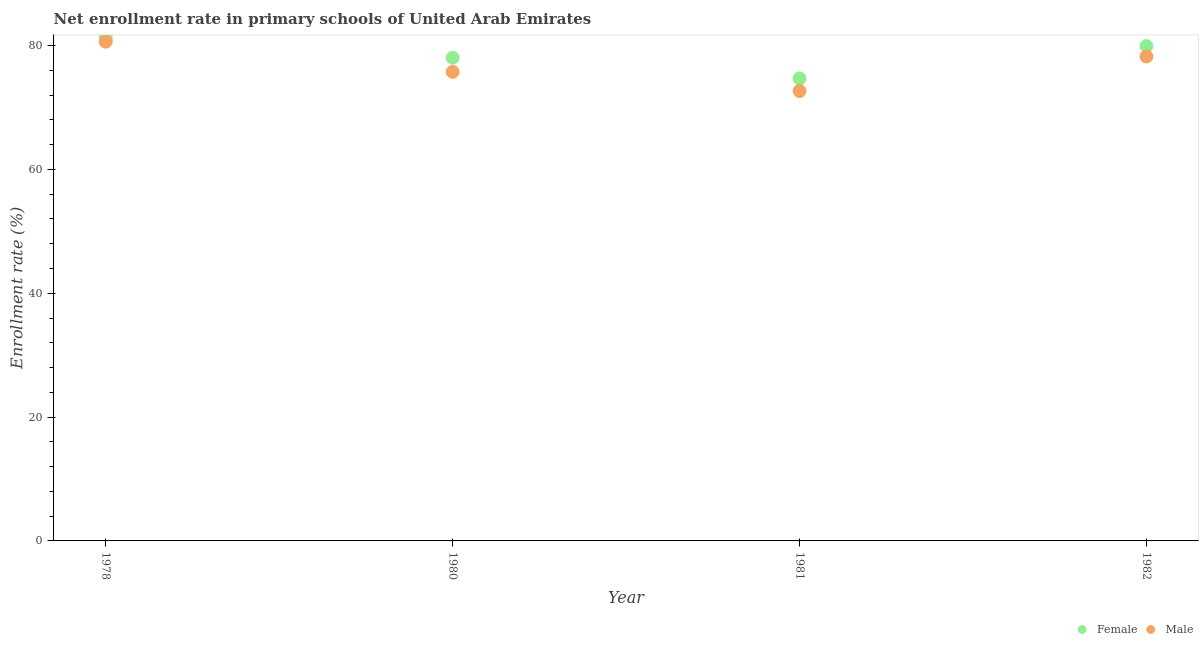How many different coloured dotlines are there?
Provide a short and direct response. 2. What is the enrollment rate of female students in 1982?
Your response must be concise. 79.92. Across all years, what is the maximum enrollment rate of female students?
Make the answer very short. 81.29. Across all years, what is the minimum enrollment rate of male students?
Provide a succinct answer. 72.66. In which year was the enrollment rate of male students maximum?
Provide a succinct answer. 1978. What is the total enrollment rate of female students in the graph?
Make the answer very short. 313.94. What is the difference between the enrollment rate of male students in 1978 and that in 1980?
Ensure brevity in your answer.  4.88. What is the difference between the enrollment rate of female students in 1982 and the enrollment rate of male students in 1980?
Your answer should be compact. 4.16. What is the average enrollment rate of male students per year?
Your answer should be very brief. 76.82. In the year 1980, what is the difference between the enrollment rate of male students and enrollment rate of female students?
Your answer should be very brief. -2.28. In how many years, is the enrollment rate of male students greater than 68 %?
Make the answer very short. 4. What is the ratio of the enrollment rate of male students in 1978 to that in 1982?
Offer a very short reply. 1.03. What is the difference between the highest and the second highest enrollment rate of female students?
Your response must be concise. 1.38. What is the difference between the highest and the lowest enrollment rate of male students?
Provide a short and direct response. 7.97. Is the sum of the enrollment rate of male students in 1978 and 1982 greater than the maximum enrollment rate of female students across all years?
Provide a short and direct response. Yes. Is the enrollment rate of female students strictly less than the enrollment rate of male students over the years?
Provide a short and direct response. No. How many years are there in the graph?
Your response must be concise. 4. Does the graph contain any zero values?
Ensure brevity in your answer.  No. Does the graph contain grids?
Keep it short and to the point. No. Where does the legend appear in the graph?
Make the answer very short. Bottom right. How many legend labels are there?
Keep it short and to the point. 2. How are the legend labels stacked?
Your answer should be very brief. Horizontal. What is the title of the graph?
Your answer should be compact. Net enrollment rate in primary schools of United Arab Emirates. Does "Drinking water services" appear as one of the legend labels in the graph?
Offer a very short reply. No. What is the label or title of the Y-axis?
Your answer should be very brief. Enrollment rate (%). What is the Enrollment rate (%) of Female in 1978?
Keep it short and to the point. 81.29. What is the Enrollment rate (%) of Male in 1978?
Ensure brevity in your answer.  80.63. What is the Enrollment rate (%) of Female in 1980?
Provide a succinct answer. 78.03. What is the Enrollment rate (%) in Male in 1980?
Offer a terse response. 75.75. What is the Enrollment rate (%) of Female in 1981?
Provide a succinct answer. 74.7. What is the Enrollment rate (%) in Male in 1981?
Make the answer very short. 72.66. What is the Enrollment rate (%) of Female in 1982?
Keep it short and to the point. 79.92. What is the Enrollment rate (%) of Male in 1982?
Your answer should be compact. 78.23. Across all years, what is the maximum Enrollment rate (%) of Female?
Your answer should be compact. 81.29. Across all years, what is the maximum Enrollment rate (%) of Male?
Offer a terse response. 80.63. Across all years, what is the minimum Enrollment rate (%) of Female?
Offer a very short reply. 74.7. Across all years, what is the minimum Enrollment rate (%) in Male?
Make the answer very short. 72.66. What is the total Enrollment rate (%) in Female in the graph?
Offer a very short reply. 313.94. What is the total Enrollment rate (%) of Male in the graph?
Keep it short and to the point. 307.27. What is the difference between the Enrollment rate (%) of Female in 1978 and that in 1980?
Your answer should be compact. 3.26. What is the difference between the Enrollment rate (%) of Male in 1978 and that in 1980?
Provide a short and direct response. 4.88. What is the difference between the Enrollment rate (%) of Female in 1978 and that in 1981?
Keep it short and to the point. 6.6. What is the difference between the Enrollment rate (%) in Male in 1978 and that in 1981?
Make the answer very short. 7.97. What is the difference between the Enrollment rate (%) of Female in 1978 and that in 1982?
Provide a succinct answer. 1.38. What is the difference between the Enrollment rate (%) in Male in 1978 and that in 1982?
Your answer should be compact. 2.4. What is the difference between the Enrollment rate (%) in Female in 1980 and that in 1981?
Make the answer very short. 3.34. What is the difference between the Enrollment rate (%) in Male in 1980 and that in 1981?
Your answer should be compact. 3.09. What is the difference between the Enrollment rate (%) of Female in 1980 and that in 1982?
Provide a succinct answer. -1.88. What is the difference between the Enrollment rate (%) of Male in 1980 and that in 1982?
Your answer should be compact. -2.48. What is the difference between the Enrollment rate (%) of Female in 1981 and that in 1982?
Make the answer very short. -5.22. What is the difference between the Enrollment rate (%) of Male in 1981 and that in 1982?
Ensure brevity in your answer.  -5.57. What is the difference between the Enrollment rate (%) of Female in 1978 and the Enrollment rate (%) of Male in 1980?
Make the answer very short. 5.54. What is the difference between the Enrollment rate (%) in Female in 1978 and the Enrollment rate (%) in Male in 1981?
Ensure brevity in your answer.  8.63. What is the difference between the Enrollment rate (%) in Female in 1978 and the Enrollment rate (%) in Male in 1982?
Your answer should be very brief. 3.06. What is the difference between the Enrollment rate (%) of Female in 1980 and the Enrollment rate (%) of Male in 1981?
Your answer should be very brief. 5.37. What is the difference between the Enrollment rate (%) in Female in 1980 and the Enrollment rate (%) in Male in 1982?
Keep it short and to the point. -0.2. What is the difference between the Enrollment rate (%) of Female in 1981 and the Enrollment rate (%) of Male in 1982?
Make the answer very short. -3.54. What is the average Enrollment rate (%) of Female per year?
Offer a very short reply. 78.48. What is the average Enrollment rate (%) of Male per year?
Your answer should be very brief. 76.82. In the year 1978, what is the difference between the Enrollment rate (%) in Female and Enrollment rate (%) in Male?
Keep it short and to the point. 0.66. In the year 1980, what is the difference between the Enrollment rate (%) in Female and Enrollment rate (%) in Male?
Your response must be concise. 2.28. In the year 1981, what is the difference between the Enrollment rate (%) in Female and Enrollment rate (%) in Male?
Keep it short and to the point. 2.03. In the year 1982, what is the difference between the Enrollment rate (%) in Female and Enrollment rate (%) in Male?
Ensure brevity in your answer.  1.68. What is the ratio of the Enrollment rate (%) of Female in 1978 to that in 1980?
Provide a short and direct response. 1.04. What is the ratio of the Enrollment rate (%) in Male in 1978 to that in 1980?
Provide a succinct answer. 1.06. What is the ratio of the Enrollment rate (%) of Female in 1978 to that in 1981?
Your answer should be compact. 1.09. What is the ratio of the Enrollment rate (%) of Male in 1978 to that in 1981?
Offer a very short reply. 1.11. What is the ratio of the Enrollment rate (%) in Female in 1978 to that in 1982?
Make the answer very short. 1.02. What is the ratio of the Enrollment rate (%) in Male in 1978 to that in 1982?
Ensure brevity in your answer.  1.03. What is the ratio of the Enrollment rate (%) in Female in 1980 to that in 1981?
Make the answer very short. 1.04. What is the ratio of the Enrollment rate (%) in Male in 1980 to that in 1981?
Ensure brevity in your answer.  1.04. What is the ratio of the Enrollment rate (%) of Female in 1980 to that in 1982?
Your response must be concise. 0.98. What is the ratio of the Enrollment rate (%) in Male in 1980 to that in 1982?
Your answer should be compact. 0.97. What is the ratio of the Enrollment rate (%) in Female in 1981 to that in 1982?
Provide a short and direct response. 0.93. What is the ratio of the Enrollment rate (%) of Male in 1981 to that in 1982?
Provide a short and direct response. 0.93. What is the difference between the highest and the second highest Enrollment rate (%) in Female?
Give a very brief answer. 1.38. What is the difference between the highest and the second highest Enrollment rate (%) in Male?
Your answer should be very brief. 2.4. What is the difference between the highest and the lowest Enrollment rate (%) in Female?
Give a very brief answer. 6.6. What is the difference between the highest and the lowest Enrollment rate (%) of Male?
Offer a very short reply. 7.97. 